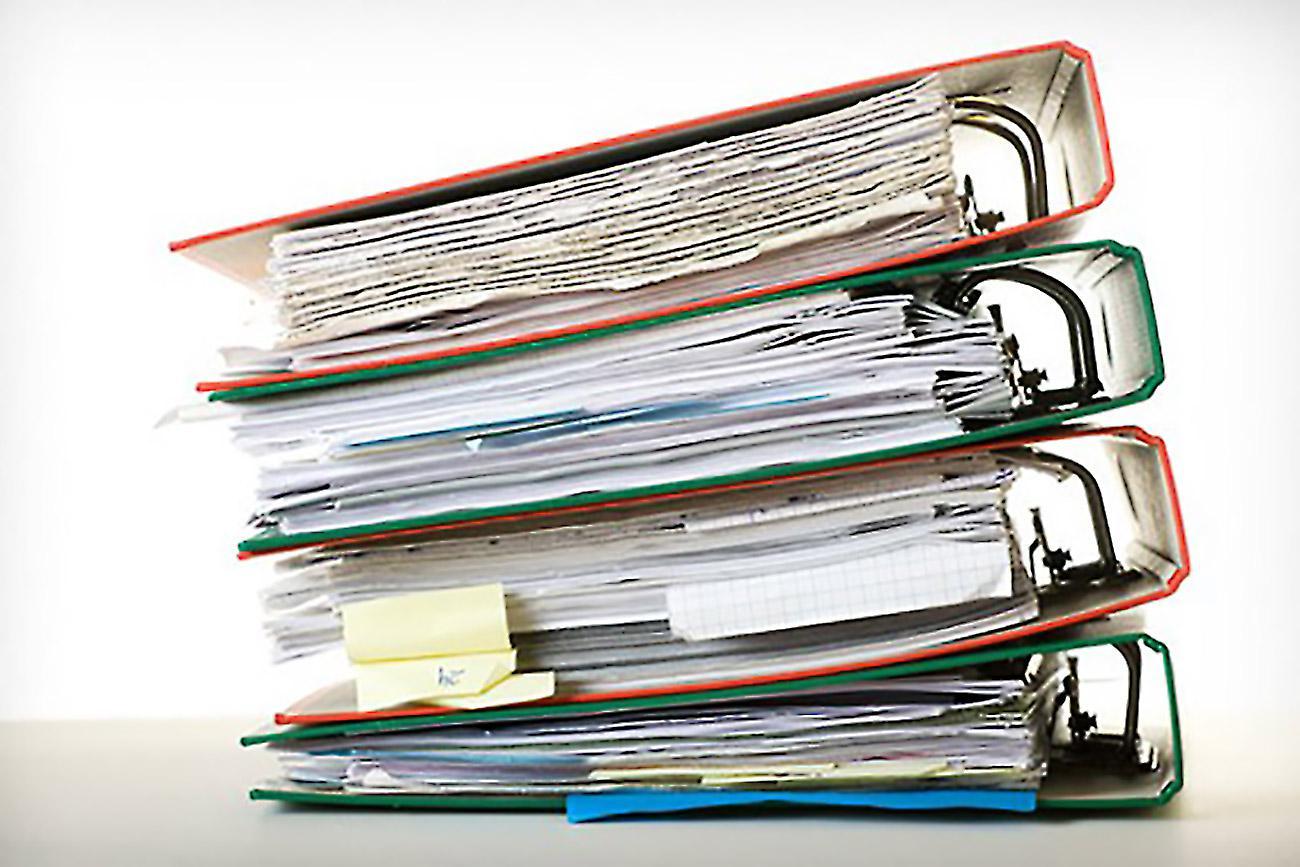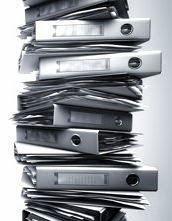The first image is the image on the left, the second image is the image on the right. Considering the images on both sides, is "The left image has binders with visible labels." valid? Answer yes or no. No. The first image is the image on the left, the second image is the image on the right. For the images shown, is this caption "An image shows the labeled ends of three stacked binders of different colors." true? Answer yes or no. No. 